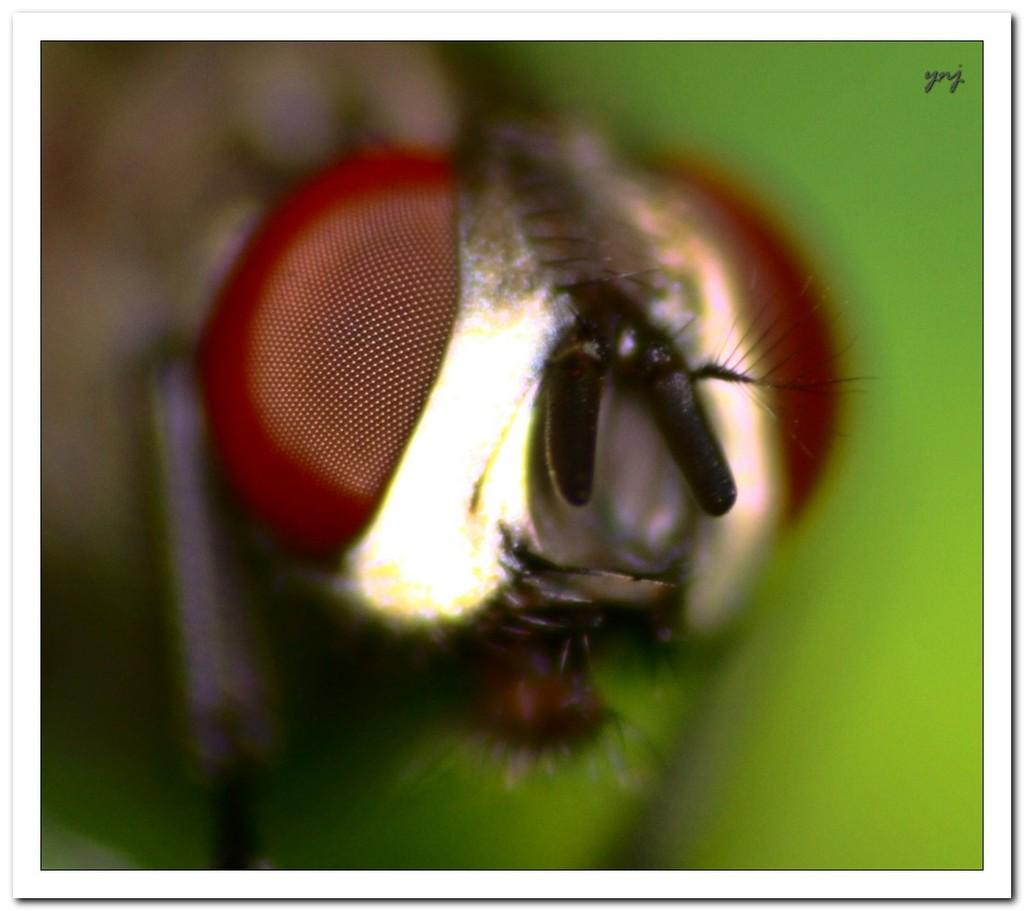What type of creature can be seen in the image? There is an insect in the image. Can you describe the background of the image? The background of the image is blurred. What type of line can be seen connecting the insect to the land in the image? There is no line connecting the insect to the land in the image. What type of lock is visible on the insect in the image? There is no lock present on the insect in the image. 